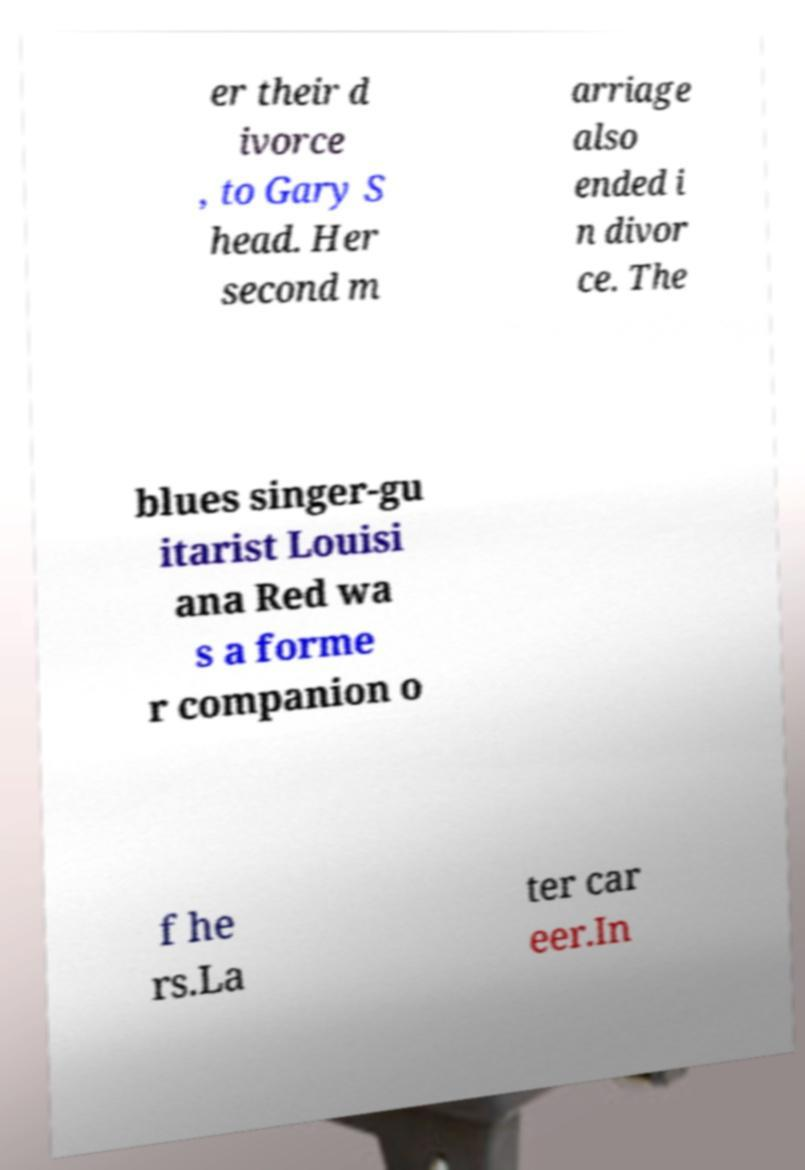Please read and relay the text visible in this image. What does it say? er their d ivorce , to Gary S head. Her second m arriage also ended i n divor ce. The blues singer-gu itarist Louisi ana Red wa s a forme r companion o f he rs.La ter car eer.In 